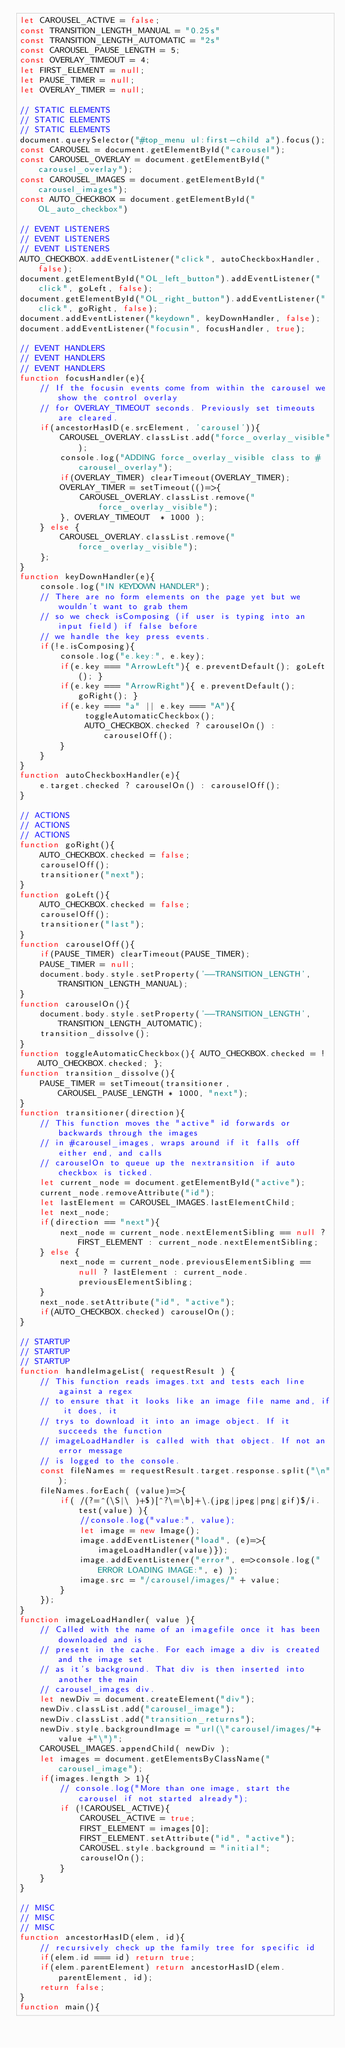<code> <loc_0><loc_0><loc_500><loc_500><_JavaScript_>let CAROUSEL_ACTIVE = false;
const TRANSITION_LENGTH_MANUAL = "0.25s"
const TRANSITION_LENGTH_AUTOMATIC = "2s"
const CAROUSEL_PAUSE_LENGTH = 5;
const OVERLAY_TIMEOUT = 4;
let FIRST_ELEMENT = null;
let PAUSE_TIMER = null;
let OVERLAY_TIMER = null;

// STATIC ELEMENTS
// STATIC ELEMENTS
// STATIC ELEMENTS
document.querySelector("#top_menu ul:first-child a").focus();
const CAROUSEL = document.getElementById("carousel");
const CAROUSEL_OVERLAY = document.getElementById("carousel_overlay");
const CAROUSEL_IMAGES = document.getElementById("carousel_images");
const AUTO_CHECKBOX = document.getElementById("OL_auto_checkbox")

// EVENT LISTENERS
// EVENT LISTENERS
// EVENT LISTENERS
AUTO_CHECKBOX.addEventListener("click", autoCheckboxHandler, false);
document.getElementById("OL_left_button").addEventListener("click", goLeft, false);
document.getElementById("OL_right_button").addEventListener("click", goRight, false);
document.addEventListener("keydown", keyDownHandler, false);
document.addEventListener("focusin", focusHandler, true);

// EVENT HANDLERS
// EVENT HANDLERS
// EVENT HANDLERS
function focusHandler(e){
    // If the focusin events come from within the carousel we show the control overlay
    // for OVERLAY_TIMEOUT seconds. Previously set timeouts are cleared.
    if(ancestorHasID(e.srcElement, 'carousel')){
        CAROUSEL_OVERLAY.classList.add("force_overlay_visible");
        console.log("ADDING force_overlay_visible class to #carousel_overlay");
        if(OVERLAY_TIMER) clearTimeout(OVERLAY_TIMER);
        OVERLAY_TIMER = setTimeout(()=>{
            CAROUSEL_OVERLAY.classList.remove("force_overlay_visible");
        }, OVERLAY_TIMEOUT  * 1000 );
    } else {
        CAROUSEL_OVERLAY.classList.remove("force_overlay_visible"); 
    };
}       
function keyDownHandler(e){
    console.log("IN KEYDOWN HANDLER");
    // There are no form elements on the page yet but we wouldn't want to grab them
    // so we check isComposing (if user is typing into an input field) if false before
    // we handle the key press events. 
    if(!e.isComposing){
        console.log("e.key:", e.key);
        if(e.key === "ArrowLeft"){ e.preventDefault(); goLeft(); }
        if(e.key === "ArrowRight"){ e.preventDefault(); goRight(); }
        if(e.key === "a" || e.key === "A"){
             toggleAutomaticCheckbox();
             AUTO_CHECKBOX.checked ? carouselOn() : carouselOff();
        }
    }
}
function autoCheckboxHandler(e){
    e.target.checked ? carouselOn() : carouselOff();
}

// ACTIONS
// ACTIONS
// ACTIONS
function goRight(){
    AUTO_CHECKBOX.checked = false;
    carouselOff();
    transitioner("next");
}
function goLeft(){
    AUTO_CHECKBOX.checked = false;
    carouselOff();
    transitioner("last");
}
function carouselOff(){
    if(PAUSE_TIMER) clearTimeout(PAUSE_TIMER);
    PAUSE_TIMER = null;
    document.body.style.setProperty('--TRANSITION_LENGTH', TRANSITION_LENGTH_MANUAL);
}
function carouselOn(){
    document.body.style.setProperty('--TRANSITION_LENGTH', TRANSITION_LENGTH_AUTOMATIC);
    transition_dissolve();
}
function toggleAutomaticCheckbox(){ AUTO_CHECKBOX.checked = !AUTO_CHECKBOX.checked; };
function transition_dissolve(){
    PAUSE_TIMER = setTimeout(transitioner, CAROUSEL_PAUSE_LENGTH * 1000, "next");
}
function transitioner(direction){
    // This function moves the "active" id forwards or backwards through the images
    // in #carousel_images, wraps around if it falls off either end, and calls
    // carouselOn to queue up the nextransition if auto checkbox is ticked.
    let current_node = document.getElementById("active");
    current_node.removeAttribute("id");
    let lastElement = CAROUSEL_IMAGES.lastElementChild;
    let next_node;
    if(direction == "next"){
        next_node = current_node.nextElementSibling == null ? FIRST_ELEMENT : current_node.nextElementSibling;
    } else {
        next_node = current_node.previousElementSibling == null ? lastElement : current_node.previousElementSibling;
    }
    next_node.setAttribute("id", "active");
    if(AUTO_CHECKBOX.checked) carouselOn();
}

// STARTUP
// STARTUP
// STARTUP
function handleImageList( requestResult ) {
    // This function reads images.txt and tests each line against a regex
    // to ensure that it looks like an image file name and, if it does, it
    // trys to download it into an image object. If it succeeds the function
    // imageLoadHandler is called with that object. If not an error message
    // is logged to the console.
    const fileNames = requestResult.target.response.split("\n");
    fileNames.forEach( (value)=>{
        if( /(?=^(\S|\ )+$)[^?\=\b]+\.(jpg|jpeg|png|gif)$/i.test(value) ){
            //console.log("value:", value);
            let image = new Image();
            image.addEventListener("load", (e)=>{imageLoadHandler(value)});
            image.addEventListener("error", e=>console.log("ERROR LOADING IMAGE:", e) );
            image.src = "/carousel/images/" + value;
        }
    });
}
function imageLoadHandler( value ){
    // Called with the name of an imagefile once it has been downloaded and is
    // present in the cache. For each image a div is created and the image set
    // as it's background. That div is then inserted into another the main
    // carousel_images div.
    let newDiv = document.createElement("div");
    newDiv.classList.add("carousel_image");
    newDiv.classList.add("transition_returns");
    newDiv.style.backgroundImage = "url(\"carousel/images/"+ value +"\")";
    CAROUSEL_IMAGES.appendChild( newDiv );
    let images = document.getElementsByClassName("carousel_image");
    if(images.length > 1){
        // console.log("More than one image, start the carousel if not started already");
        if (!CAROUSEL_ACTIVE){
            CAROUSEL_ACTIVE = true;
            FIRST_ELEMENT = images[0];
            FIRST_ELEMENT.setAttribute("id", "active");
            CAROUSEL.style.background = "initial";
            carouselOn();
        }
    }
}

// MISC
// MISC
// MISC
function ancestorHasID(elem, id){
    // recursively check up the family tree for specific id
    if(elem.id === id) return true;
    if(elem.parentElement) return ancestorHasID(elem.parentElement, id);
    return false;
}
function main(){</code> 